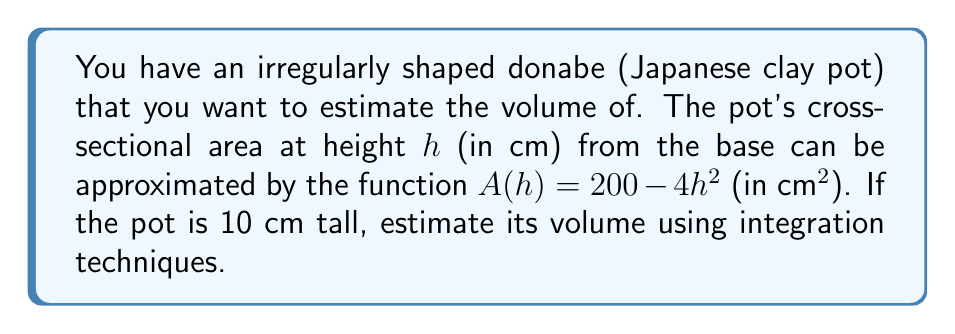What is the answer to this math problem? To estimate the volume of the irregularly shaped donabe, we need to use the integration technique. Here's how we approach this problem:

1) The volume of a solid with a known cross-sectional area function $A(h)$ from height $a$ to $b$ is given by the integral:

   $$V = \int_a^b A(h) dh$$

2) In this case, $A(h) = 200 - 4h^2$, $a = 0$ (base of the pot), and $b = 10$ (height of the pot).

3) Let's set up the integral:

   $$V = \int_0^{10} (200 - 4h^2) dh$$

4) Now, let's solve the integral:
   
   $$V = [200h - \frac{4}{3}h^3]_0^{10}$$

5) Evaluate the integral at the limits:

   $$V = (2000 - \frac{4000}{3}) - (0 - 0)$$

6) Simplify:

   $$V = 2000 - \frac{4000}{3} = \frac{6000}{3} - \frac{4000}{3} = \frac{2000}{3}$$

7) The result is in cubic centimeters (cm³). To convert to liters, divide by 1000:

   $$V = \frac{2000}{3} \cdot \frac{1}{1000} = \frac{2}{3} \approx 0.667 \text{ liters}$$
Answer: $\frac{2}{3}$ liters or approximately 0.667 liters 